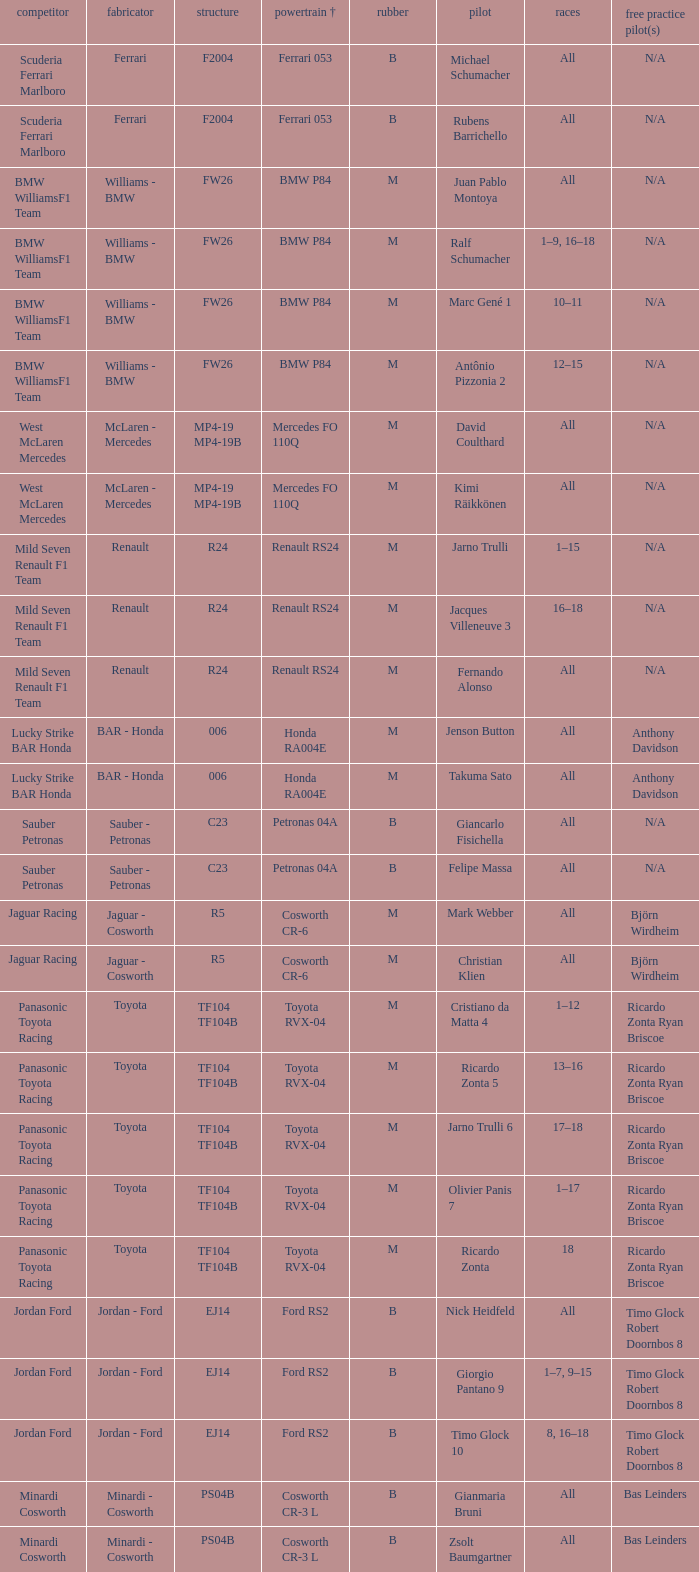What kind of chassis does Ricardo Zonta have? TF104 TF104B. 